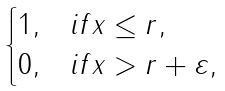<formula> <loc_0><loc_0><loc_500><loc_500>\begin{cases} 1 , & i f \| x \| \leq r , \\ 0 , & i f \| x \| > r + \varepsilon , \end{cases}</formula> 